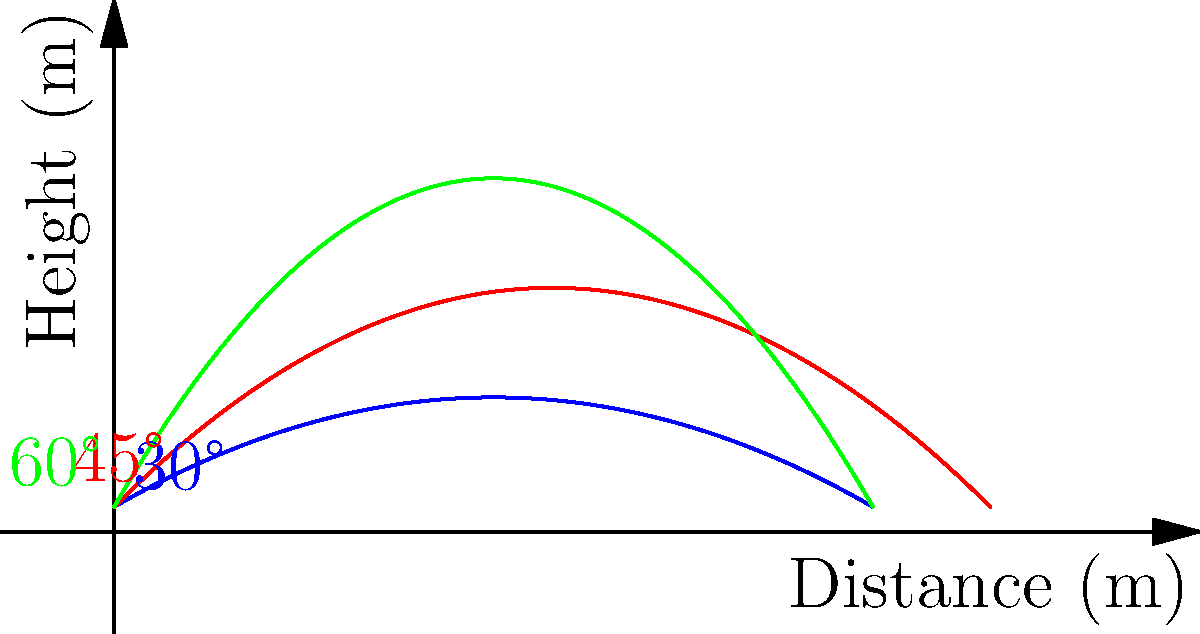As an athletics coach, you're analyzing javelin throw trajectories. The graph shows three paths for a javelin thrown at an initial velocity of 25 m/s from a height of 1.8 m, with launch angles of 30°, 45°, and 60°. Considering air resistance is negligible, which angle provides the maximum horizontal distance, and why does this differ from the theoretical 45° for projectile motion? To understand why the optimal angle differs from 45°, let's analyze the situation step-by-step:

1) The theoretical 45° angle for maximum range applies to projectiles launched from ground level (h = 0).

2) In this case, the javelin is thrown from a height of 1.8 m, which affects the optimal angle.

3) The equation for the range (R) of a projectile launched from height h is:

   $$R = \frac{v_0 \cos \theta}{g} \left(v_0 \sin \theta + \sqrt{v_0^2 \sin^2 \theta + 2gh}\right)$$

   Where $v_0$ is initial velocity, $\theta$ is launch angle, g is gravitational acceleration, and h is initial height.

4) When h > 0, the optimal angle is less than 45°. This is because the projectile has additional time to travel horizontally due to its initial height.

5) To find the exact optimal angle, we would need to differentiate the range equation with respect to θ and set it to zero. However, this is complex and usually solved numerically.

6) From the graph, we can see that the 45° trajectory (red) travels further than the 60° trajectory (green), but the 30° trajectory (blue) travels the furthest.

7) This visual evidence suggests that the optimal angle is between 30° and 45°, likely closer to 30° given the initial height.

Therefore, the 30° launch angle provides the maximum horizontal distance in this scenario, demonstrating how the presence of initial height shifts the optimal angle below 45°.
Answer: 30°; initial height shifts optimal angle below 45° 